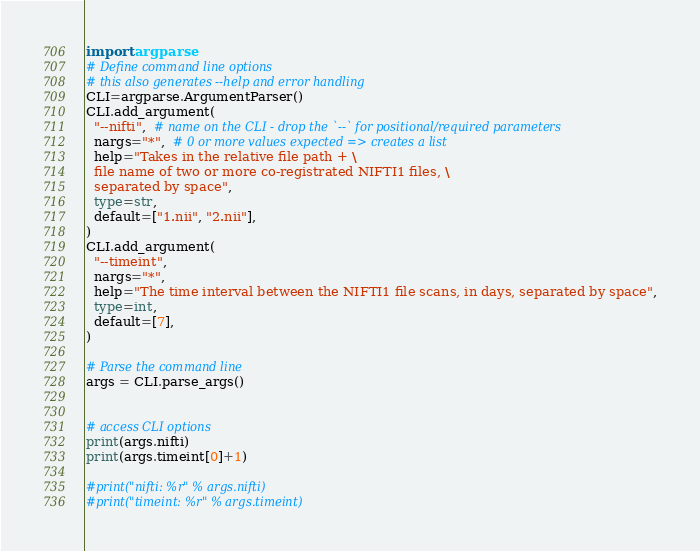<code> <loc_0><loc_0><loc_500><loc_500><_Python_>import argparse
# Define command line options
# this also generates --help and error handling
CLI=argparse.ArgumentParser()
CLI.add_argument(
  "--nifti",  # name on the CLI - drop the `--` for positional/required parameters
  nargs="*",  # 0 or more values expected => creates a list
  help="Takes in the relative file path + \
  file name of two or more co-registrated NIFTI1 files, \
  separated by space",
  type=str,
  default=["1.nii", "2.nii"],
)
CLI.add_argument(
  "--timeint",
  nargs="*",
  help="The time interval between the NIFTI1 file scans, in days, separated by space",
  type=int,
  default=[7],
)

# Parse the command line
args = CLI.parse_args()


# access CLI options
print(args.nifti)
print(args.timeint[0]+1)

#print("nifti: %r" % args.nifti)
#print("timeint: %r" % args.timeint)</code> 